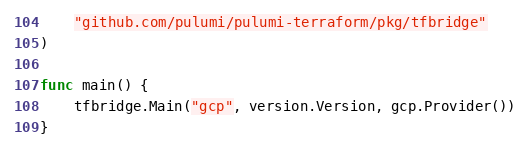Convert code to text. <code><loc_0><loc_0><loc_500><loc_500><_Go_>	"github.com/pulumi/pulumi-terraform/pkg/tfbridge"
)

func main() {
	tfbridge.Main("gcp", version.Version, gcp.Provider())
}
</code> 